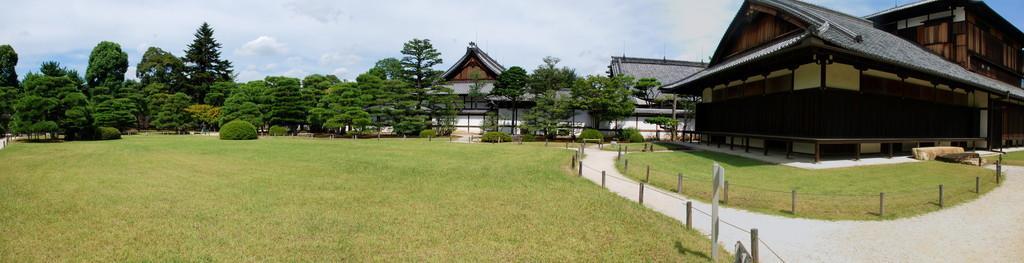Describe this image in one or two sentences. In the background we can see the sky. in this picture we can see houses, rooftops, fences, board, pole, plants, trees, grass, pathway and objects. 